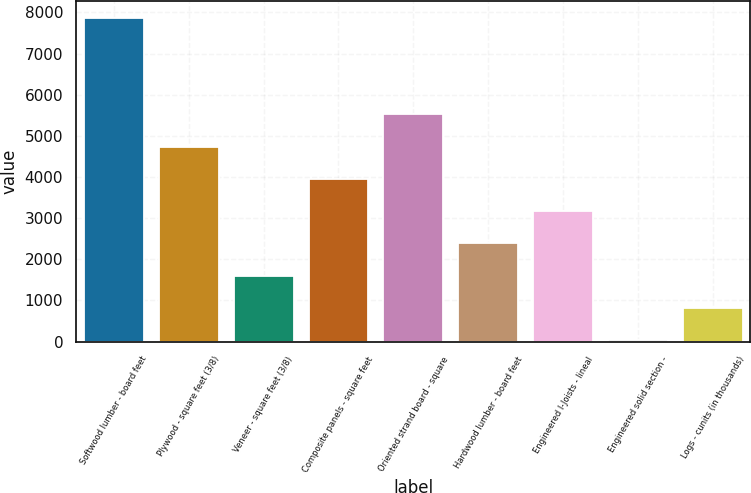Convert chart to OTSL. <chart><loc_0><loc_0><loc_500><loc_500><bar_chart><fcel>Softwood lumber - board feet<fcel>Plywood - square feet (3/8)<fcel>Veneer - square feet (3/8)<fcel>Composite panels - square feet<fcel>Oriented strand board - square<fcel>Hardwood lumber - board feet<fcel>Engineered I-Joists - lineal<fcel>Engineered solid section -<fcel>Logs - cunits (in thousands)<nl><fcel>7871<fcel>4737<fcel>1603<fcel>3953.5<fcel>5520.5<fcel>2386.5<fcel>3170<fcel>36<fcel>819.5<nl></chart> 